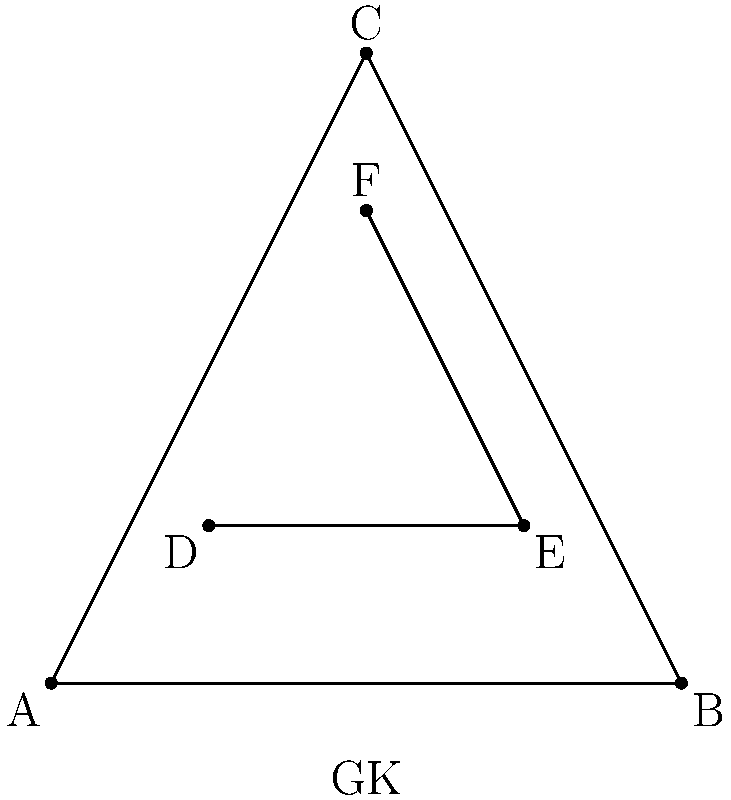Consider the soccer formation diagram above, which represents a 3-3-1 formation with a goalkeeper (GK). What is the order of the rotational symmetry group of this formation diagram? To determine the order of the rotational symmetry group, we need to follow these steps:

1. Identify the center of rotation: The center is at the midpoint of the diagram.

2. Determine the number of distinct rotations that bring the formation back to its original position:
   a) 0° rotation (identity): Always counts as 1.
   b) 120° rotation: The triangle ABC maps onto itself.
   c) 240° rotation: Again, the triangle ABC maps onto itself.

3. Count the total number of distinct rotations:
   There are 3 distinct rotations (0°, 120°, 240°) that preserve the formation's structure.

4. The order of the rotational symmetry group is equal to the number of distinct rotations.

Therefore, the order of the rotational symmetry group for this formation diagram is 3.

This symmetry aligns with the principles of tiki-taka, where players are often positioned in triangular formations to create passing options and maintain possession.
Answer: 3 